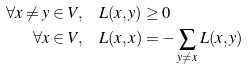<formula> <loc_0><loc_0><loc_500><loc_500>\forall x \neq y \in V , & \quad L ( x , y ) \geq 0 \\ \forall x \in V , & \quad L ( x , x ) = - \sum _ { y \neq x } L ( x , y )</formula> 